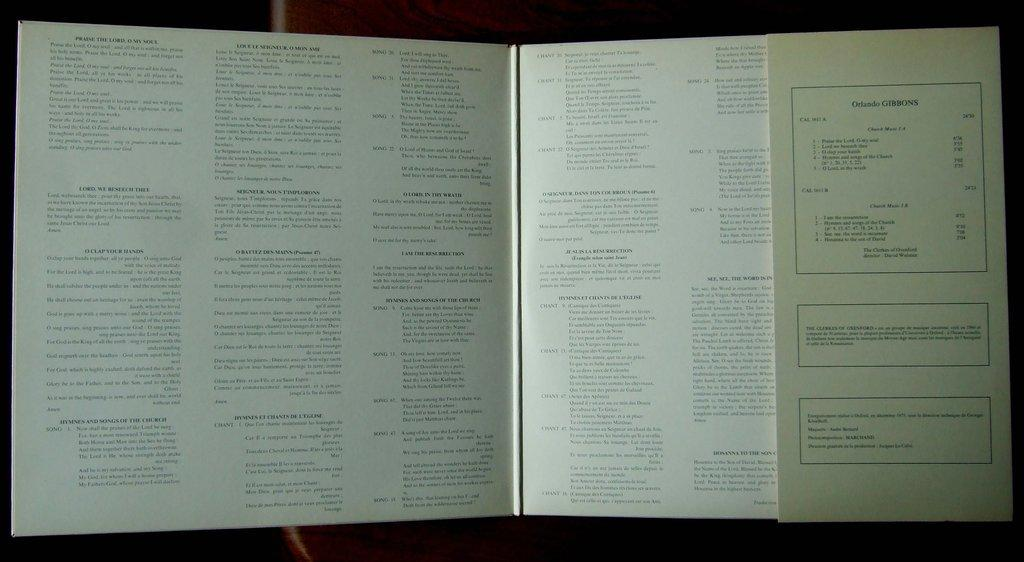<image>
Summarize the visual content of the image. A book with small text in it features the name Orlando Gibbons. 